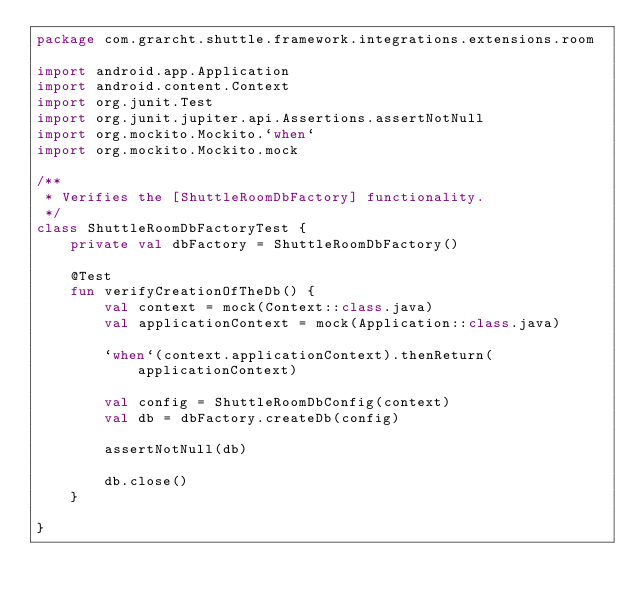Convert code to text. <code><loc_0><loc_0><loc_500><loc_500><_Kotlin_>package com.grarcht.shuttle.framework.integrations.extensions.room

import android.app.Application
import android.content.Context
import org.junit.Test
import org.junit.jupiter.api.Assertions.assertNotNull
import org.mockito.Mockito.`when`
import org.mockito.Mockito.mock

/**
 * Verifies the [ShuttleRoomDbFactory] functionality.
 */
class ShuttleRoomDbFactoryTest {
    private val dbFactory = ShuttleRoomDbFactory()

    @Test
    fun verifyCreationOfTheDb() {
        val context = mock(Context::class.java)
        val applicationContext = mock(Application::class.java)

        `when`(context.applicationContext).thenReturn(applicationContext)

        val config = ShuttleRoomDbConfig(context)
        val db = dbFactory.createDb(config)

        assertNotNull(db)

        db.close()
    }

}
</code> 